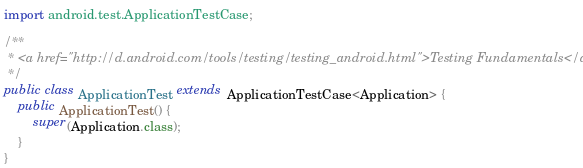Convert code to text. <code><loc_0><loc_0><loc_500><loc_500><_Java_>import android.test.ApplicationTestCase;

/**
 * <a href="http://d.android.com/tools/testing/testing_android.html">Testing Fundamentals</a>
 */
public class ApplicationTest extends ApplicationTestCase<Application> {
    public ApplicationTest() {
        super(Application.class);
    }
}</code> 